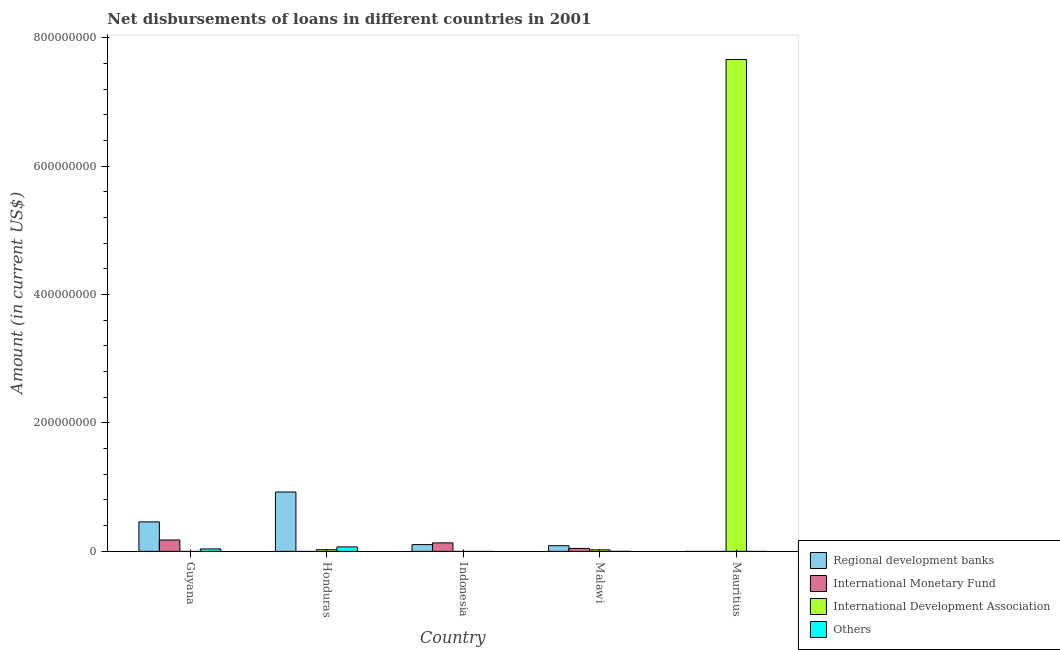Are the number of bars on each tick of the X-axis equal?
Your response must be concise. No. How many bars are there on the 2nd tick from the left?
Provide a short and direct response. 3. What is the label of the 5th group of bars from the left?
Offer a very short reply. Mauritius. What is the amount of loan disimbursed by international development association in Honduras?
Offer a terse response. 2.52e+06. Across all countries, what is the maximum amount of loan disimbursed by regional development banks?
Provide a short and direct response. 9.24e+07. In which country was the amount of loan disimbursed by other organisations maximum?
Your answer should be compact. Honduras. What is the total amount of loan disimbursed by international monetary fund in the graph?
Ensure brevity in your answer.  3.55e+07. What is the difference between the amount of loan disimbursed by international monetary fund in Guyana and that in Malawi?
Give a very brief answer. 1.31e+07. What is the difference between the amount of loan disimbursed by regional development banks in Guyana and the amount of loan disimbursed by international monetary fund in Indonesia?
Your response must be concise. 3.27e+07. What is the average amount of loan disimbursed by regional development banks per country?
Provide a succinct answer. 3.15e+07. What is the difference between the amount of loan disimbursed by regional development banks and amount of loan disimbursed by international development association in Honduras?
Your answer should be very brief. 8.99e+07. In how many countries, is the amount of loan disimbursed by international development association greater than 120000000 US$?
Provide a short and direct response. 1. What is the ratio of the amount of loan disimbursed by international development association in Honduras to that in Malawi?
Provide a short and direct response. 1.06. What is the difference between the highest and the second highest amount of loan disimbursed by regional development banks?
Your response must be concise. 4.65e+07. What is the difference between the highest and the lowest amount of loan disimbursed by international development association?
Your answer should be very brief. 7.66e+08. In how many countries, is the amount of loan disimbursed by regional development banks greater than the average amount of loan disimbursed by regional development banks taken over all countries?
Provide a succinct answer. 2. Is the sum of the amount of loan disimbursed by international development association in Honduras and Malawi greater than the maximum amount of loan disimbursed by international monetary fund across all countries?
Offer a terse response. No. Are all the bars in the graph horizontal?
Offer a very short reply. No. Are the values on the major ticks of Y-axis written in scientific E-notation?
Your answer should be compact. No. Does the graph contain any zero values?
Provide a succinct answer. Yes. Does the graph contain grids?
Your answer should be very brief. No. How many legend labels are there?
Provide a succinct answer. 4. How are the legend labels stacked?
Your answer should be compact. Vertical. What is the title of the graph?
Your response must be concise. Net disbursements of loans in different countries in 2001. What is the label or title of the X-axis?
Your answer should be very brief. Country. What is the Amount (in current US$) of Regional development banks in Guyana?
Keep it short and to the point. 4.59e+07. What is the Amount (in current US$) in International Monetary Fund in Guyana?
Offer a very short reply. 1.77e+07. What is the Amount (in current US$) in Others in Guyana?
Offer a terse response. 3.78e+06. What is the Amount (in current US$) of Regional development banks in Honduras?
Your response must be concise. 9.24e+07. What is the Amount (in current US$) of International Development Association in Honduras?
Your answer should be very brief. 2.52e+06. What is the Amount (in current US$) of Others in Honduras?
Ensure brevity in your answer.  6.89e+06. What is the Amount (in current US$) of Regional development banks in Indonesia?
Provide a succinct answer. 1.05e+07. What is the Amount (in current US$) of International Monetary Fund in Indonesia?
Make the answer very short. 1.32e+07. What is the Amount (in current US$) in Others in Indonesia?
Give a very brief answer. 0. What is the Amount (in current US$) of Regional development banks in Malawi?
Keep it short and to the point. 8.80e+06. What is the Amount (in current US$) in International Monetary Fund in Malawi?
Your answer should be compact. 4.59e+06. What is the Amount (in current US$) of International Development Association in Malawi?
Provide a short and direct response. 2.37e+06. What is the Amount (in current US$) of Others in Malawi?
Offer a terse response. 0. What is the Amount (in current US$) in Regional development banks in Mauritius?
Offer a terse response. 0. What is the Amount (in current US$) of International Monetary Fund in Mauritius?
Provide a succinct answer. 0. What is the Amount (in current US$) of International Development Association in Mauritius?
Ensure brevity in your answer.  7.66e+08. What is the Amount (in current US$) of Others in Mauritius?
Provide a short and direct response. 0. Across all countries, what is the maximum Amount (in current US$) of Regional development banks?
Your answer should be very brief. 9.24e+07. Across all countries, what is the maximum Amount (in current US$) of International Monetary Fund?
Offer a very short reply. 1.77e+07. Across all countries, what is the maximum Amount (in current US$) of International Development Association?
Ensure brevity in your answer.  7.66e+08. Across all countries, what is the maximum Amount (in current US$) in Others?
Offer a terse response. 6.89e+06. Across all countries, what is the minimum Amount (in current US$) in Regional development banks?
Your answer should be very brief. 0. What is the total Amount (in current US$) of Regional development banks in the graph?
Make the answer very short. 1.58e+08. What is the total Amount (in current US$) of International Monetary Fund in the graph?
Provide a succinct answer. 3.55e+07. What is the total Amount (in current US$) of International Development Association in the graph?
Your response must be concise. 7.71e+08. What is the total Amount (in current US$) in Others in the graph?
Offer a very short reply. 1.07e+07. What is the difference between the Amount (in current US$) of Regional development banks in Guyana and that in Honduras?
Provide a short and direct response. -4.65e+07. What is the difference between the Amount (in current US$) in Others in Guyana and that in Honduras?
Keep it short and to the point. -3.11e+06. What is the difference between the Amount (in current US$) in Regional development banks in Guyana and that in Indonesia?
Ensure brevity in your answer.  3.54e+07. What is the difference between the Amount (in current US$) in International Monetary Fund in Guyana and that in Indonesia?
Keep it short and to the point. 4.48e+06. What is the difference between the Amount (in current US$) in Regional development banks in Guyana and that in Malawi?
Your response must be concise. 3.71e+07. What is the difference between the Amount (in current US$) of International Monetary Fund in Guyana and that in Malawi?
Your answer should be very brief. 1.31e+07. What is the difference between the Amount (in current US$) of Regional development banks in Honduras and that in Indonesia?
Ensure brevity in your answer.  8.19e+07. What is the difference between the Amount (in current US$) in Regional development banks in Honduras and that in Malawi?
Your answer should be very brief. 8.36e+07. What is the difference between the Amount (in current US$) in International Development Association in Honduras and that in Malawi?
Ensure brevity in your answer.  1.51e+05. What is the difference between the Amount (in current US$) of International Development Association in Honduras and that in Mauritius?
Provide a short and direct response. -7.63e+08. What is the difference between the Amount (in current US$) of Regional development banks in Indonesia and that in Malawi?
Your answer should be very brief. 1.70e+06. What is the difference between the Amount (in current US$) of International Monetary Fund in Indonesia and that in Malawi?
Your answer should be very brief. 8.61e+06. What is the difference between the Amount (in current US$) in International Development Association in Malawi and that in Mauritius?
Give a very brief answer. -7.64e+08. What is the difference between the Amount (in current US$) of Regional development banks in Guyana and the Amount (in current US$) of International Development Association in Honduras?
Your response must be concise. 4.34e+07. What is the difference between the Amount (in current US$) of Regional development banks in Guyana and the Amount (in current US$) of Others in Honduras?
Offer a very short reply. 3.90e+07. What is the difference between the Amount (in current US$) of International Monetary Fund in Guyana and the Amount (in current US$) of International Development Association in Honduras?
Make the answer very short. 1.52e+07. What is the difference between the Amount (in current US$) in International Monetary Fund in Guyana and the Amount (in current US$) in Others in Honduras?
Give a very brief answer. 1.08e+07. What is the difference between the Amount (in current US$) in Regional development banks in Guyana and the Amount (in current US$) in International Monetary Fund in Indonesia?
Make the answer very short. 3.27e+07. What is the difference between the Amount (in current US$) in Regional development banks in Guyana and the Amount (in current US$) in International Monetary Fund in Malawi?
Keep it short and to the point. 4.13e+07. What is the difference between the Amount (in current US$) of Regional development banks in Guyana and the Amount (in current US$) of International Development Association in Malawi?
Give a very brief answer. 4.35e+07. What is the difference between the Amount (in current US$) in International Monetary Fund in Guyana and the Amount (in current US$) in International Development Association in Malawi?
Keep it short and to the point. 1.53e+07. What is the difference between the Amount (in current US$) in Regional development banks in Guyana and the Amount (in current US$) in International Development Association in Mauritius?
Ensure brevity in your answer.  -7.20e+08. What is the difference between the Amount (in current US$) in International Monetary Fund in Guyana and the Amount (in current US$) in International Development Association in Mauritius?
Make the answer very short. -7.48e+08. What is the difference between the Amount (in current US$) of Regional development banks in Honduras and the Amount (in current US$) of International Monetary Fund in Indonesia?
Make the answer very short. 7.92e+07. What is the difference between the Amount (in current US$) of Regional development banks in Honduras and the Amount (in current US$) of International Monetary Fund in Malawi?
Offer a terse response. 8.78e+07. What is the difference between the Amount (in current US$) of Regional development banks in Honduras and the Amount (in current US$) of International Development Association in Malawi?
Your response must be concise. 9.00e+07. What is the difference between the Amount (in current US$) in Regional development banks in Honduras and the Amount (in current US$) in International Development Association in Mauritius?
Your answer should be compact. -6.74e+08. What is the difference between the Amount (in current US$) of Regional development banks in Indonesia and the Amount (in current US$) of International Monetary Fund in Malawi?
Ensure brevity in your answer.  5.91e+06. What is the difference between the Amount (in current US$) in Regional development banks in Indonesia and the Amount (in current US$) in International Development Association in Malawi?
Offer a terse response. 8.13e+06. What is the difference between the Amount (in current US$) in International Monetary Fund in Indonesia and the Amount (in current US$) in International Development Association in Malawi?
Ensure brevity in your answer.  1.08e+07. What is the difference between the Amount (in current US$) in Regional development banks in Indonesia and the Amount (in current US$) in International Development Association in Mauritius?
Make the answer very short. -7.56e+08. What is the difference between the Amount (in current US$) of International Monetary Fund in Indonesia and the Amount (in current US$) of International Development Association in Mauritius?
Your response must be concise. -7.53e+08. What is the difference between the Amount (in current US$) of Regional development banks in Malawi and the Amount (in current US$) of International Development Association in Mauritius?
Give a very brief answer. -7.57e+08. What is the difference between the Amount (in current US$) of International Monetary Fund in Malawi and the Amount (in current US$) of International Development Association in Mauritius?
Provide a short and direct response. -7.61e+08. What is the average Amount (in current US$) in Regional development banks per country?
Your response must be concise. 3.15e+07. What is the average Amount (in current US$) of International Monetary Fund per country?
Make the answer very short. 7.09e+06. What is the average Amount (in current US$) of International Development Association per country?
Your answer should be compact. 1.54e+08. What is the average Amount (in current US$) of Others per country?
Offer a terse response. 2.13e+06. What is the difference between the Amount (in current US$) in Regional development banks and Amount (in current US$) in International Monetary Fund in Guyana?
Make the answer very short. 2.82e+07. What is the difference between the Amount (in current US$) in Regional development banks and Amount (in current US$) in Others in Guyana?
Give a very brief answer. 4.21e+07. What is the difference between the Amount (in current US$) of International Monetary Fund and Amount (in current US$) of Others in Guyana?
Offer a very short reply. 1.39e+07. What is the difference between the Amount (in current US$) in Regional development banks and Amount (in current US$) in International Development Association in Honduras?
Make the answer very short. 8.99e+07. What is the difference between the Amount (in current US$) of Regional development banks and Amount (in current US$) of Others in Honduras?
Offer a terse response. 8.55e+07. What is the difference between the Amount (in current US$) of International Development Association and Amount (in current US$) of Others in Honduras?
Your answer should be compact. -4.37e+06. What is the difference between the Amount (in current US$) in Regional development banks and Amount (in current US$) in International Monetary Fund in Indonesia?
Your answer should be compact. -2.70e+06. What is the difference between the Amount (in current US$) of Regional development banks and Amount (in current US$) of International Monetary Fund in Malawi?
Your response must be concise. 4.21e+06. What is the difference between the Amount (in current US$) in Regional development banks and Amount (in current US$) in International Development Association in Malawi?
Make the answer very short. 6.43e+06. What is the difference between the Amount (in current US$) of International Monetary Fund and Amount (in current US$) of International Development Association in Malawi?
Your answer should be very brief. 2.22e+06. What is the ratio of the Amount (in current US$) of Regional development banks in Guyana to that in Honduras?
Offer a very short reply. 0.5. What is the ratio of the Amount (in current US$) of Others in Guyana to that in Honduras?
Your answer should be compact. 0.55. What is the ratio of the Amount (in current US$) in Regional development banks in Guyana to that in Indonesia?
Offer a terse response. 4.37. What is the ratio of the Amount (in current US$) in International Monetary Fund in Guyana to that in Indonesia?
Give a very brief answer. 1.34. What is the ratio of the Amount (in current US$) of Regional development banks in Guyana to that in Malawi?
Your answer should be compact. 5.22. What is the ratio of the Amount (in current US$) in International Monetary Fund in Guyana to that in Malawi?
Your response must be concise. 3.85. What is the ratio of the Amount (in current US$) in Regional development banks in Honduras to that in Indonesia?
Keep it short and to the point. 8.81. What is the ratio of the Amount (in current US$) in Regional development banks in Honduras to that in Malawi?
Keep it short and to the point. 10.5. What is the ratio of the Amount (in current US$) in International Development Association in Honduras to that in Malawi?
Provide a short and direct response. 1.06. What is the ratio of the Amount (in current US$) in International Development Association in Honduras to that in Mauritius?
Your response must be concise. 0. What is the ratio of the Amount (in current US$) of Regional development banks in Indonesia to that in Malawi?
Provide a succinct answer. 1.19. What is the ratio of the Amount (in current US$) of International Monetary Fund in Indonesia to that in Malawi?
Your answer should be very brief. 2.88. What is the ratio of the Amount (in current US$) in International Development Association in Malawi to that in Mauritius?
Your response must be concise. 0. What is the difference between the highest and the second highest Amount (in current US$) of Regional development banks?
Your answer should be compact. 4.65e+07. What is the difference between the highest and the second highest Amount (in current US$) in International Monetary Fund?
Your response must be concise. 4.48e+06. What is the difference between the highest and the second highest Amount (in current US$) of International Development Association?
Offer a terse response. 7.63e+08. What is the difference between the highest and the lowest Amount (in current US$) of Regional development banks?
Your response must be concise. 9.24e+07. What is the difference between the highest and the lowest Amount (in current US$) of International Monetary Fund?
Make the answer very short. 1.77e+07. What is the difference between the highest and the lowest Amount (in current US$) in International Development Association?
Offer a terse response. 7.66e+08. What is the difference between the highest and the lowest Amount (in current US$) of Others?
Keep it short and to the point. 6.89e+06. 